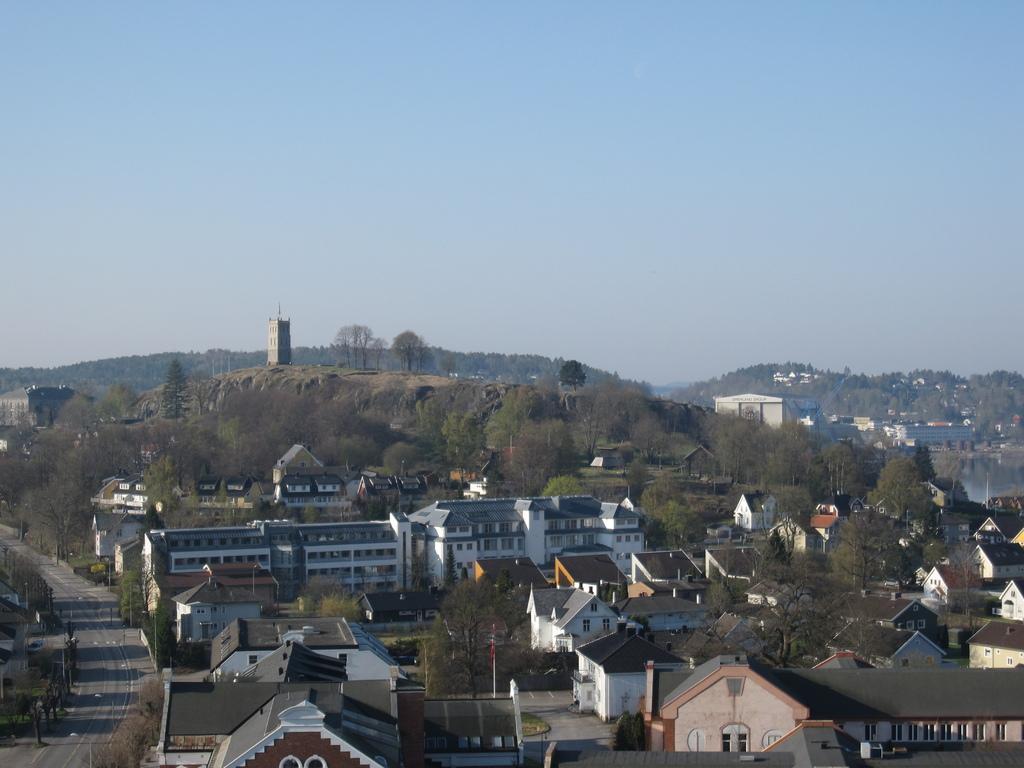Describe this image in one or two sentences. In this image I can see the road, few poles, few trees and few buildings. In the background I can see a mountain, few buildings on the mountain, few trees, the water and the sky. 